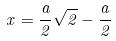Convert formula to latex. <formula><loc_0><loc_0><loc_500><loc_500>x = \frac { a } { 2 } \sqrt { 2 } - \frac { a } { 2 }</formula> 